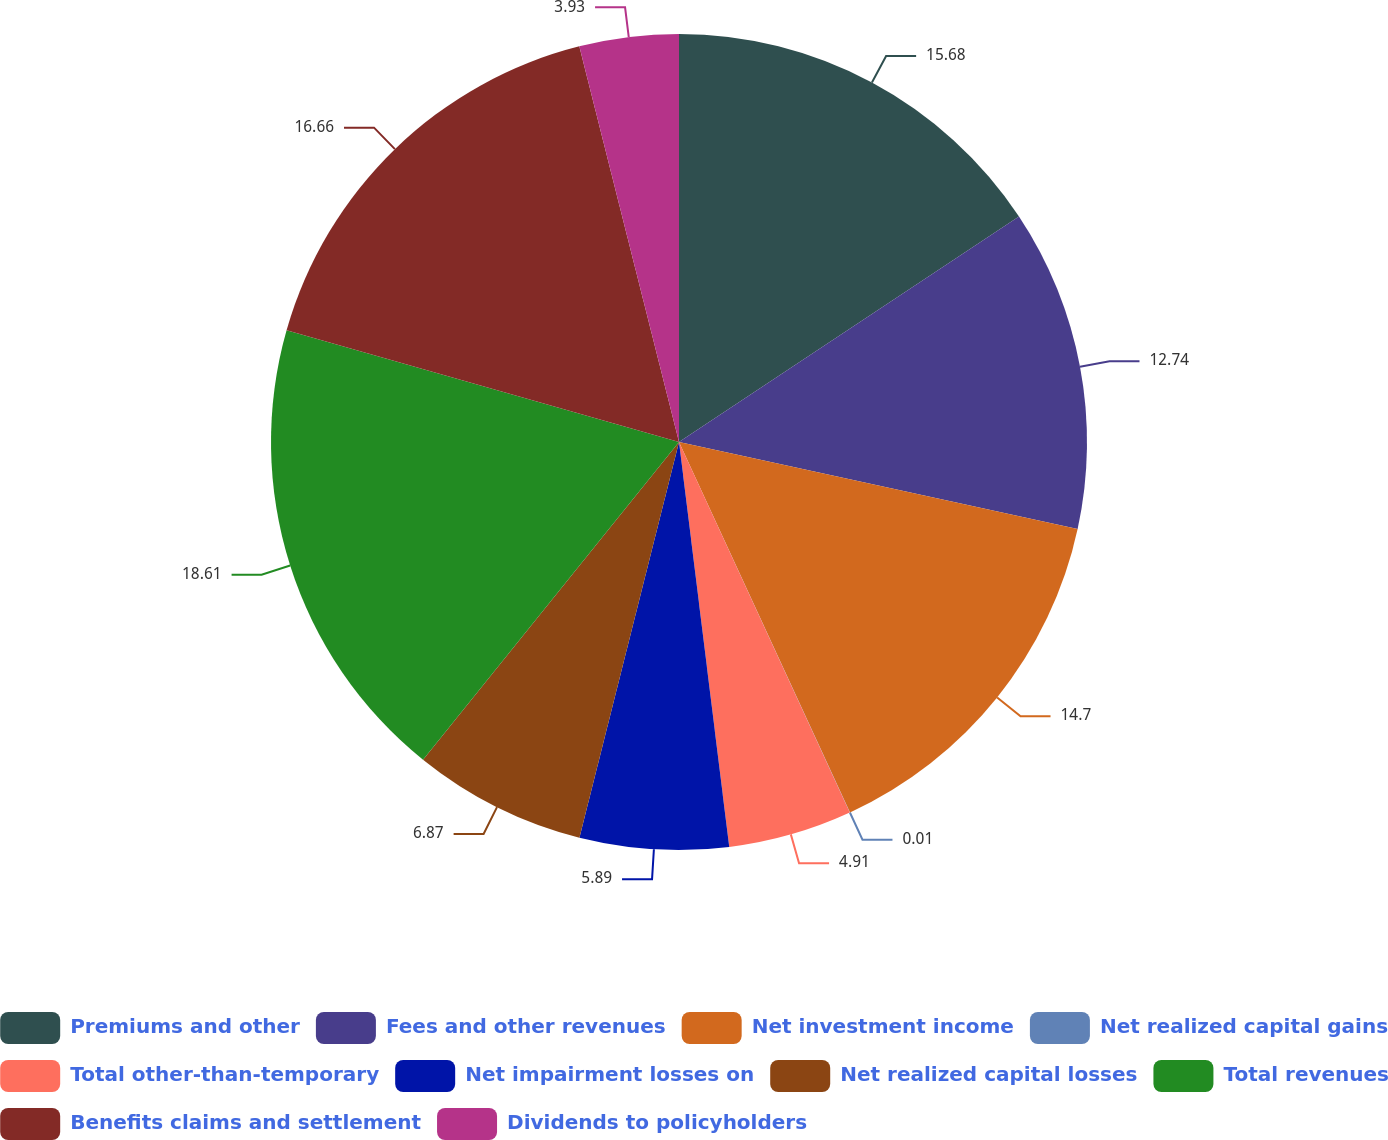Convert chart to OTSL. <chart><loc_0><loc_0><loc_500><loc_500><pie_chart><fcel>Premiums and other<fcel>Fees and other revenues<fcel>Net investment income<fcel>Net realized capital gains<fcel>Total other-than-temporary<fcel>Net impairment losses on<fcel>Net realized capital losses<fcel>Total revenues<fcel>Benefits claims and settlement<fcel>Dividends to policyholders<nl><fcel>15.68%<fcel>12.74%<fcel>14.7%<fcel>0.01%<fcel>4.91%<fcel>5.89%<fcel>6.87%<fcel>18.62%<fcel>16.66%<fcel>3.93%<nl></chart> 